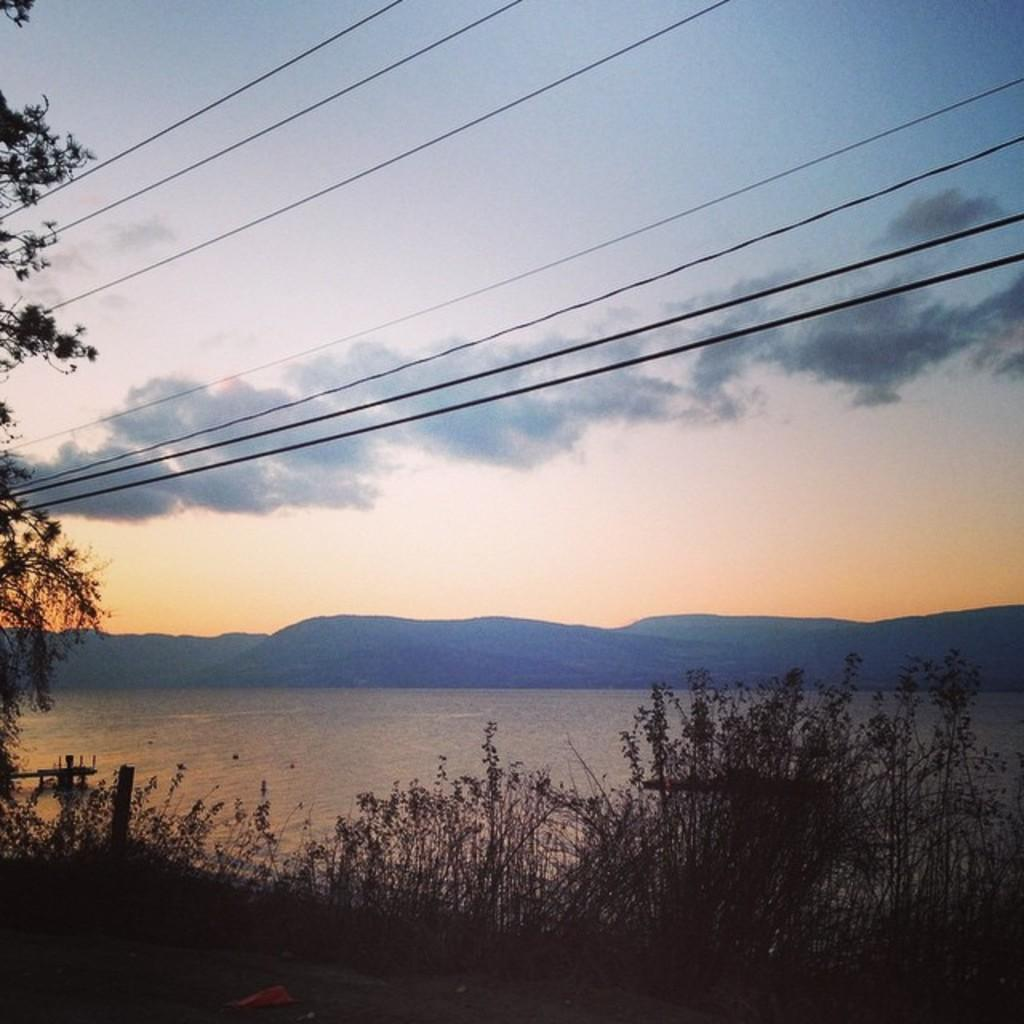What is the main element present in the image? There is water in the image. What other natural elements can be seen in the image? There are plants, hills, and a tree in the image. Are there any man-made structures visible in the image? Yes, electric wires are visible in the image. How would you describe the weather in the image? The sky is cloudy in the image. What type of balls are being used in the war depicted in the image? There is no war or balls present in the image; it features water, plants, hills, electric wires, a tree, and a cloudy sky. How is the parcel being delivered in the image? There is no parcel present in the image. 